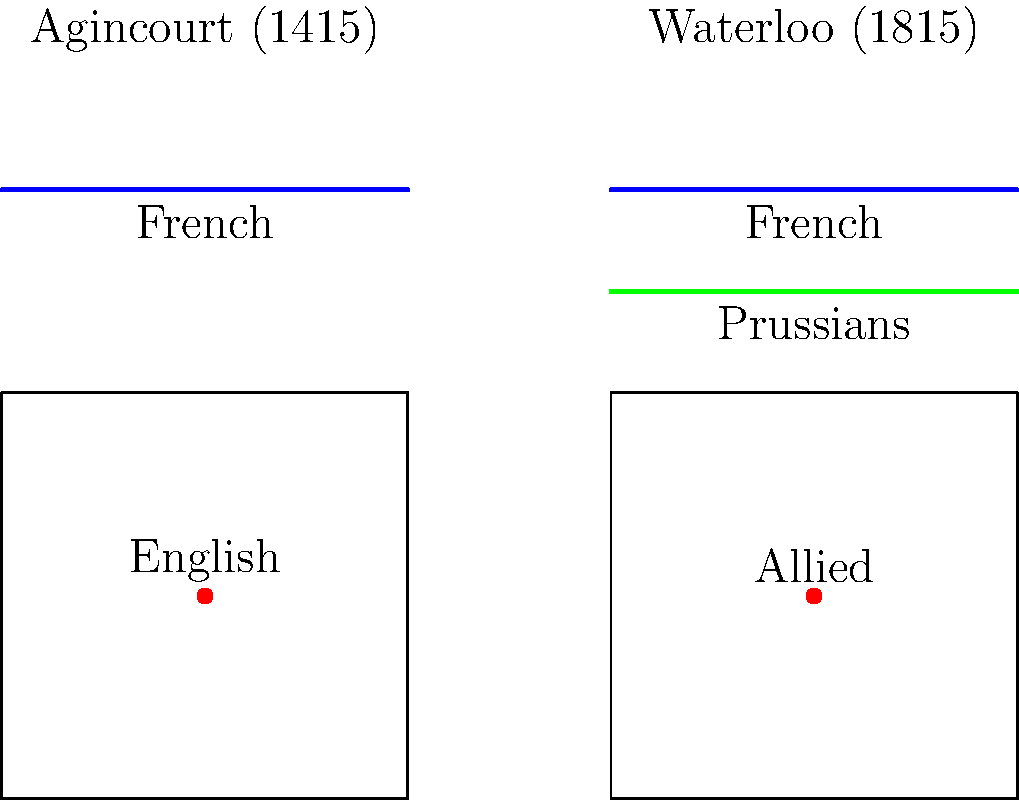Examine the battlefield diagrams of Agincourt (1415) and Waterloo (1815). How do these representations reflect the evolution of battlefield tactics over four centuries, particularly in terms of the positioning and movement of forces? 1. Battle of Agincourt (1415):
   - English forces (red dot) are centrally positioned.
   - French forces (blue line) are in a single, linear formation.
   - This represents medieval tactics with a focus on direct confrontation.

2. Battle of Waterloo (1815):
   - Allied forces (red dot) are centrally positioned, similar to Agincourt.
   - French forces (blue line) are again in a linear formation.
   - Prussian forces (green line) appear as a separate entity.

3. Evolution of tactics:
   - Agincourt shows a simple, two-sided confrontation typical of medieval warfare.
   - Waterloo demonstrates more complex tactics with multiple forces.
   - The addition of Prussian forces indicates the importance of coordinated attacks and reinforcements.

4. Changes in warfare:
   - Transition from heavy reliance on melee combat (Agincourt) to more ranged warfare (Waterloo).
   - Increased importance of maneuverability and flanking movements (Prussian involvement at Waterloo).
   - Greater emphasis on strategic positioning and timing of engagements.

5. Technological advancements:
   - While not explicitly shown, the tactics reflect the shift from longbows and knights (Agincourt) to muskets and artillery (Waterloo).

6. Scale and complexity:
   - Waterloo involves larger armies and more complex formations, reflecting the growth of nation-states and professional armies.

The evolution from Agincourt to Waterloo represents a shift from relatively simple, direct confrontations to more complex, multi-faceted engagements involving coordinated movements and strategic positioning of multiple forces.
Answer: Shift from direct confrontations to complex, multi-force engagements with emphasis on strategic positioning and coordinated attacks. 